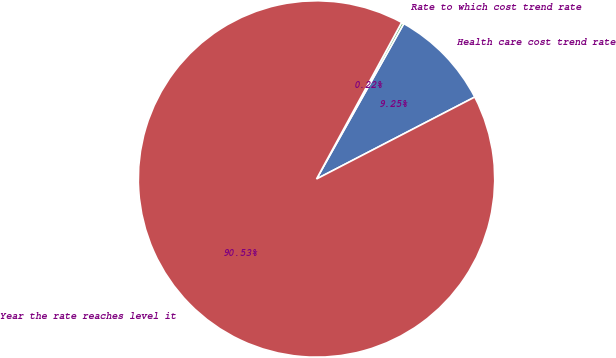Convert chart to OTSL. <chart><loc_0><loc_0><loc_500><loc_500><pie_chart><fcel>Health care cost trend rate<fcel>Rate to which cost trend rate<fcel>Year the rate reaches level it<nl><fcel>9.25%<fcel>0.22%<fcel>90.52%<nl></chart> 